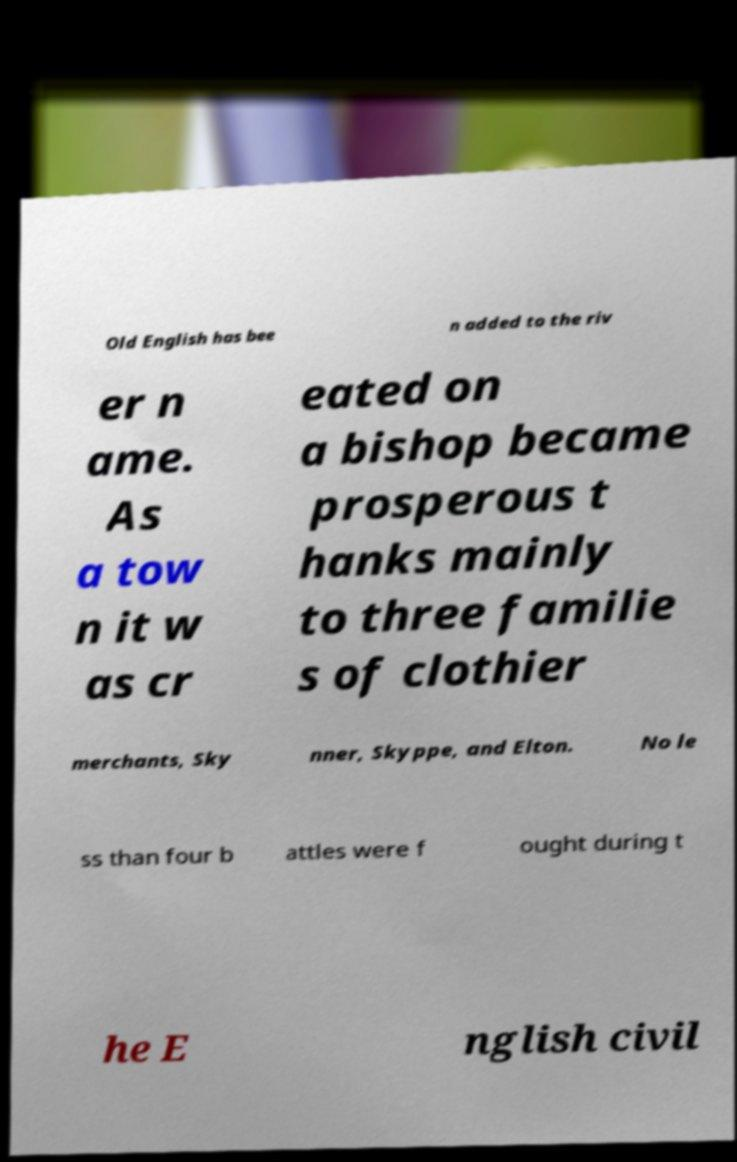Please read and relay the text visible in this image. What does it say? Old English has bee n added to the riv er n ame. As a tow n it w as cr eated on a bishop became prosperous t hanks mainly to three familie s of clothier merchants, Sky nner, Skyppe, and Elton. No le ss than four b attles were f ought during t he E nglish civil 